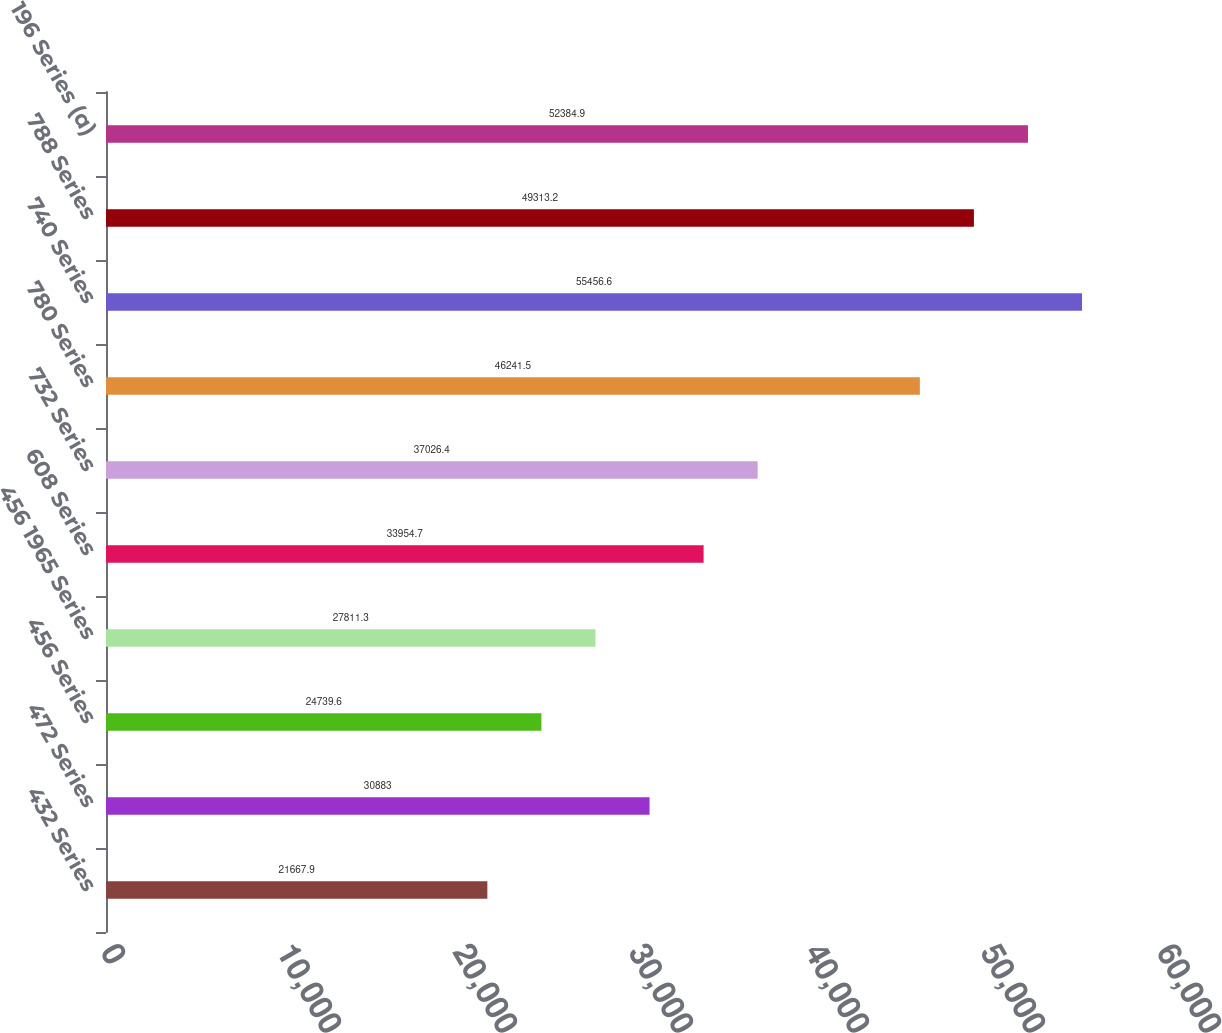Convert chart. <chart><loc_0><loc_0><loc_500><loc_500><bar_chart><fcel>432 Series<fcel>472 Series<fcel>456 Series<fcel>456 1965 Series<fcel>608 Series<fcel>732 Series<fcel>780 Series<fcel>740 Series<fcel>788 Series<fcel>196 Series (a)<nl><fcel>21667.9<fcel>30883<fcel>24739.6<fcel>27811.3<fcel>33954.7<fcel>37026.4<fcel>46241.5<fcel>55456.6<fcel>49313.2<fcel>52384.9<nl></chart> 